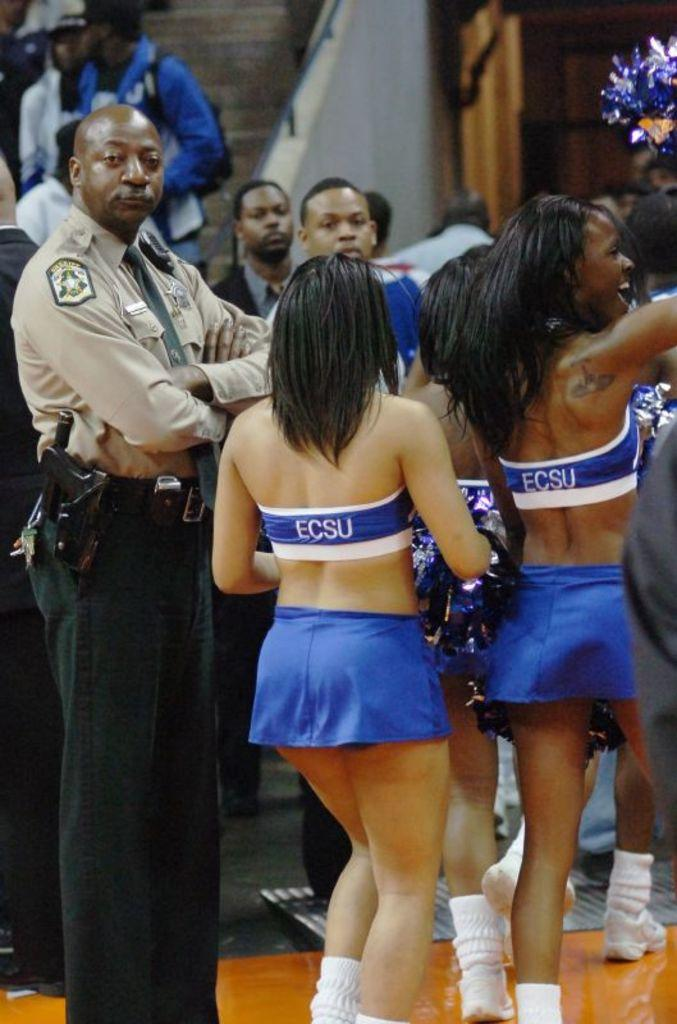<image>
Summarize the visual content of the image. The cheerleaders here are from the college ECSU 